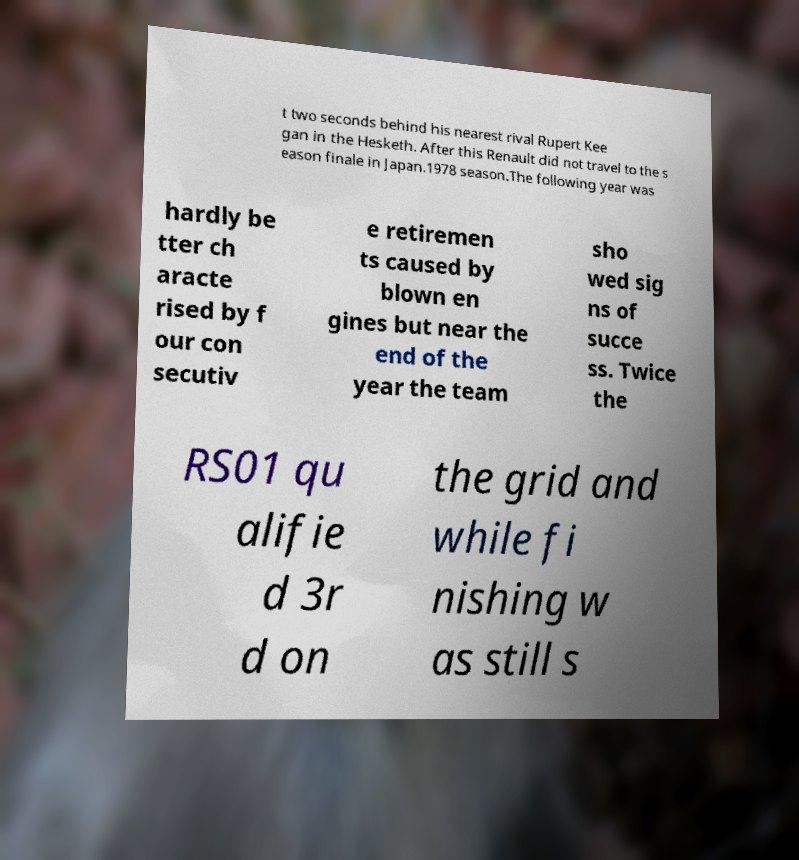Could you assist in decoding the text presented in this image and type it out clearly? t two seconds behind his nearest rival Rupert Kee gan in the Hesketh. After this Renault did not travel to the s eason finale in Japan.1978 season.The following year was hardly be tter ch aracte rised by f our con secutiv e retiremen ts caused by blown en gines but near the end of the year the team sho wed sig ns of succe ss. Twice the RS01 qu alifie d 3r d on the grid and while fi nishing w as still s 